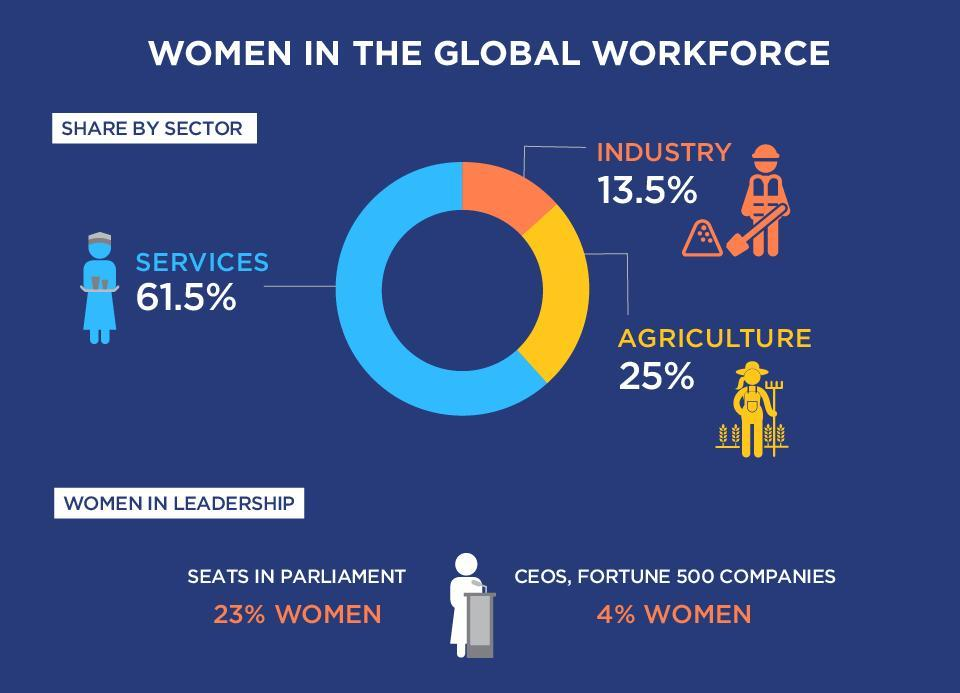Which sector has the second highest percentage of women ?
Answer the question with a short phrase. Agriculture What percentage of women are in leadership roles in Fortune 500 companies, 23%, 4%, or 13.5%? 4% What is the percentage difference of women working in services and industries? 48% 